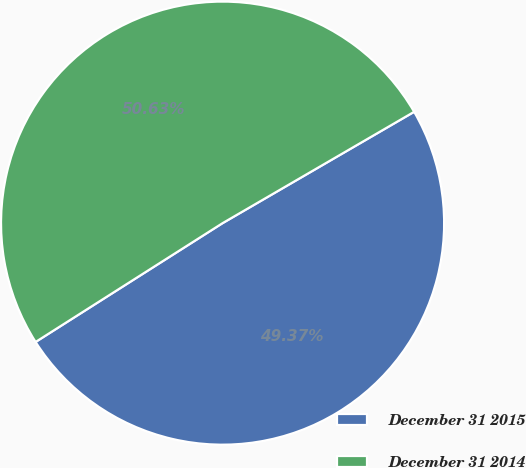Convert chart. <chart><loc_0><loc_0><loc_500><loc_500><pie_chart><fcel>December 31 2015<fcel>December 31 2014<nl><fcel>49.37%<fcel>50.63%<nl></chart> 